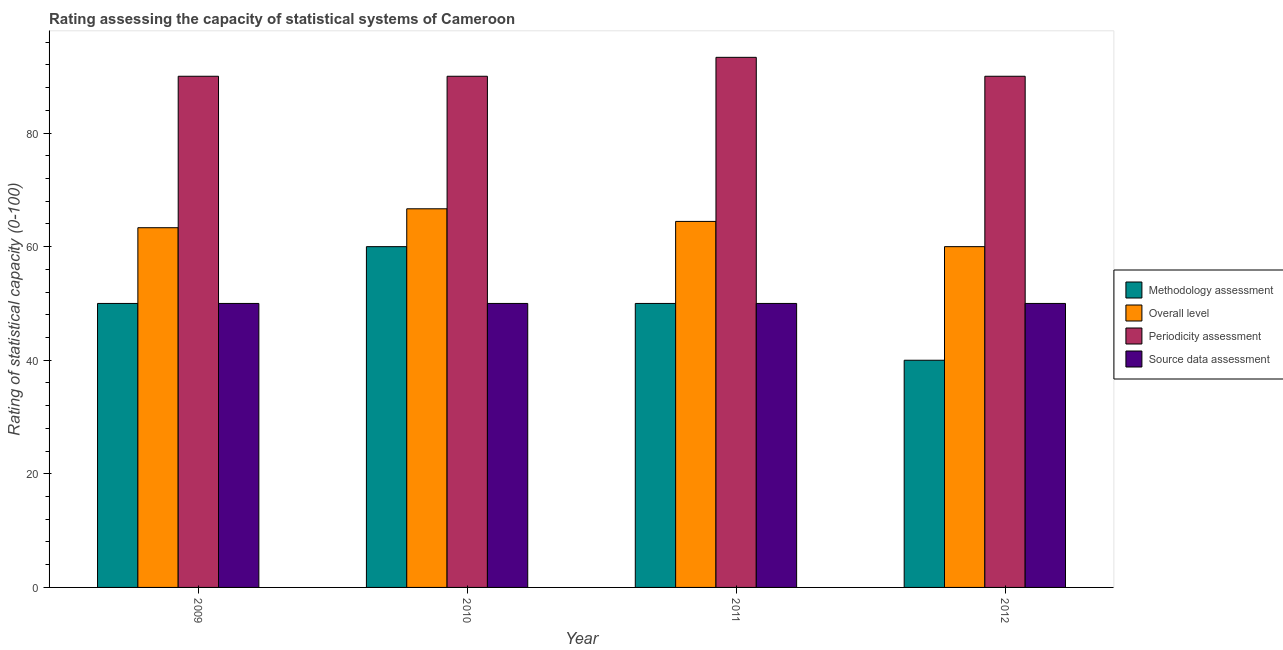How many groups of bars are there?
Provide a short and direct response. 4. How many bars are there on the 4th tick from the left?
Provide a short and direct response. 4. How many bars are there on the 4th tick from the right?
Offer a very short reply. 4. In how many cases, is the number of bars for a given year not equal to the number of legend labels?
Your answer should be very brief. 0. What is the overall level rating in 2011?
Make the answer very short. 64.44. Across all years, what is the maximum periodicity assessment rating?
Your answer should be compact. 93.33. Across all years, what is the minimum methodology assessment rating?
Provide a short and direct response. 40. In which year was the overall level rating maximum?
Give a very brief answer. 2010. In which year was the source data assessment rating minimum?
Ensure brevity in your answer.  2009. What is the total overall level rating in the graph?
Provide a succinct answer. 254.44. What is the difference between the methodology assessment rating in 2011 and that in 2012?
Ensure brevity in your answer.  10. What is the difference between the overall level rating in 2012 and the periodicity assessment rating in 2010?
Offer a very short reply. -6.67. What is the average methodology assessment rating per year?
Provide a short and direct response. 50. What is the ratio of the overall level rating in 2009 to that in 2012?
Keep it short and to the point. 1.06. Is the difference between the overall level rating in 2009 and 2010 greater than the difference between the methodology assessment rating in 2009 and 2010?
Offer a terse response. No. What is the difference between the highest and the second highest overall level rating?
Give a very brief answer. 2.22. What is the difference between the highest and the lowest overall level rating?
Provide a short and direct response. 6.67. In how many years, is the overall level rating greater than the average overall level rating taken over all years?
Offer a very short reply. 2. Is the sum of the source data assessment rating in 2009 and 2011 greater than the maximum periodicity assessment rating across all years?
Offer a terse response. Yes. Is it the case that in every year, the sum of the methodology assessment rating and source data assessment rating is greater than the sum of overall level rating and periodicity assessment rating?
Your response must be concise. No. What does the 3rd bar from the left in 2011 represents?
Ensure brevity in your answer.  Periodicity assessment. What does the 3rd bar from the right in 2012 represents?
Keep it short and to the point. Overall level. Is it the case that in every year, the sum of the methodology assessment rating and overall level rating is greater than the periodicity assessment rating?
Your response must be concise. Yes. How many bars are there?
Provide a succinct answer. 16. Are all the bars in the graph horizontal?
Give a very brief answer. No. What is the difference between two consecutive major ticks on the Y-axis?
Your answer should be compact. 20. Does the graph contain any zero values?
Offer a very short reply. No. Does the graph contain grids?
Provide a succinct answer. No. Where does the legend appear in the graph?
Make the answer very short. Center right. How many legend labels are there?
Make the answer very short. 4. How are the legend labels stacked?
Provide a succinct answer. Vertical. What is the title of the graph?
Provide a succinct answer. Rating assessing the capacity of statistical systems of Cameroon. What is the label or title of the X-axis?
Your answer should be very brief. Year. What is the label or title of the Y-axis?
Keep it short and to the point. Rating of statistical capacity (0-100). What is the Rating of statistical capacity (0-100) of Methodology assessment in 2009?
Keep it short and to the point. 50. What is the Rating of statistical capacity (0-100) of Overall level in 2009?
Your response must be concise. 63.33. What is the Rating of statistical capacity (0-100) of Periodicity assessment in 2009?
Your response must be concise. 90. What is the Rating of statistical capacity (0-100) in Source data assessment in 2009?
Make the answer very short. 50. What is the Rating of statistical capacity (0-100) of Methodology assessment in 2010?
Give a very brief answer. 60. What is the Rating of statistical capacity (0-100) of Overall level in 2010?
Keep it short and to the point. 66.67. What is the Rating of statistical capacity (0-100) of Overall level in 2011?
Offer a terse response. 64.44. What is the Rating of statistical capacity (0-100) of Periodicity assessment in 2011?
Provide a succinct answer. 93.33. What is the Rating of statistical capacity (0-100) of Source data assessment in 2011?
Your answer should be compact. 50. What is the Rating of statistical capacity (0-100) of Overall level in 2012?
Your answer should be very brief. 60. What is the Rating of statistical capacity (0-100) of Source data assessment in 2012?
Your answer should be very brief. 50. Across all years, what is the maximum Rating of statistical capacity (0-100) of Overall level?
Your response must be concise. 66.67. Across all years, what is the maximum Rating of statistical capacity (0-100) in Periodicity assessment?
Your response must be concise. 93.33. Across all years, what is the maximum Rating of statistical capacity (0-100) in Source data assessment?
Provide a succinct answer. 50. Across all years, what is the minimum Rating of statistical capacity (0-100) of Periodicity assessment?
Your answer should be very brief. 90. What is the total Rating of statistical capacity (0-100) in Methodology assessment in the graph?
Offer a very short reply. 200. What is the total Rating of statistical capacity (0-100) of Overall level in the graph?
Offer a very short reply. 254.44. What is the total Rating of statistical capacity (0-100) in Periodicity assessment in the graph?
Ensure brevity in your answer.  363.33. What is the total Rating of statistical capacity (0-100) in Source data assessment in the graph?
Provide a succinct answer. 200. What is the difference between the Rating of statistical capacity (0-100) in Overall level in 2009 and that in 2010?
Your answer should be compact. -3.33. What is the difference between the Rating of statistical capacity (0-100) in Periodicity assessment in 2009 and that in 2010?
Offer a very short reply. 0. What is the difference between the Rating of statistical capacity (0-100) of Source data assessment in 2009 and that in 2010?
Your response must be concise. 0. What is the difference between the Rating of statistical capacity (0-100) in Overall level in 2009 and that in 2011?
Keep it short and to the point. -1.11. What is the difference between the Rating of statistical capacity (0-100) of Periodicity assessment in 2009 and that in 2011?
Your answer should be compact. -3.33. What is the difference between the Rating of statistical capacity (0-100) in Methodology assessment in 2009 and that in 2012?
Ensure brevity in your answer.  10. What is the difference between the Rating of statistical capacity (0-100) in Overall level in 2009 and that in 2012?
Make the answer very short. 3.33. What is the difference between the Rating of statistical capacity (0-100) of Periodicity assessment in 2009 and that in 2012?
Your answer should be very brief. 0. What is the difference between the Rating of statistical capacity (0-100) of Source data assessment in 2009 and that in 2012?
Provide a short and direct response. 0. What is the difference between the Rating of statistical capacity (0-100) of Methodology assessment in 2010 and that in 2011?
Offer a very short reply. 10. What is the difference between the Rating of statistical capacity (0-100) of Overall level in 2010 and that in 2011?
Provide a succinct answer. 2.22. What is the difference between the Rating of statistical capacity (0-100) in Periodicity assessment in 2010 and that in 2011?
Ensure brevity in your answer.  -3.33. What is the difference between the Rating of statistical capacity (0-100) of Methodology assessment in 2010 and that in 2012?
Give a very brief answer. 20. What is the difference between the Rating of statistical capacity (0-100) in Overall level in 2011 and that in 2012?
Your answer should be very brief. 4.44. What is the difference between the Rating of statistical capacity (0-100) of Periodicity assessment in 2011 and that in 2012?
Provide a succinct answer. 3.33. What is the difference between the Rating of statistical capacity (0-100) of Source data assessment in 2011 and that in 2012?
Keep it short and to the point. 0. What is the difference between the Rating of statistical capacity (0-100) of Methodology assessment in 2009 and the Rating of statistical capacity (0-100) of Overall level in 2010?
Provide a succinct answer. -16.67. What is the difference between the Rating of statistical capacity (0-100) in Methodology assessment in 2009 and the Rating of statistical capacity (0-100) in Source data assessment in 2010?
Give a very brief answer. 0. What is the difference between the Rating of statistical capacity (0-100) of Overall level in 2009 and the Rating of statistical capacity (0-100) of Periodicity assessment in 2010?
Make the answer very short. -26.67. What is the difference between the Rating of statistical capacity (0-100) in Overall level in 2009 and the Rating of statistical capacity (0-100) in Source data assessment in 2010?
Give a very brief answer. 13.33. What is the difference between the Rating of statistical capacity (0-100) in Methodology assessment in 2009 and the Rating of statistical capacity (0-100) in Overall level in 2011?
Your answer should be very brief. -14.44. What is the difference between the Rating of statistical capacity (0-100) in Methodology assessment in 2009 and the Rating of statistical capacity (0-100) in Periodicity assessment in 2011?
Your answer should be very brief. -43.33. What is the difference between the Rating of statistical capacity (0-100) of Methodology assessment in 2009 and the Rating of statistical capacity (0-100) of Source data assessment in 2011?
Offer a very short reply. 0. What is the difference between the Rating of statistical capacity (0-100) in Overall level in 2009 and the Rating of statistical capacity (0-100) in Periodicity assessment in 2011?
Make the answer very short. -30. What is the difference between the Rating of statistical capacity (0-100) of Overall level in 2009 and the Rating of statistical capacity (0-100) of Source data assessment in 2011?
Offer a terse response. 13.33. What is the difference between the Rating of statistical capacity (0-100) in Methodology assessment in 2009 and the Rating of statistical capacity (0-100) in Source data assessment in 2012?
Provide a succinct answer. 0. What is the difference between the Rating of statistical capacity (0-100) in Overall level in 2009 and the Rating of statistical capacity (0-100) in Periodicity assessment in 2012?
Your answer should be compact. -26.67. What is the difference between the Rating of statistical capacity (0-100) in Overall level in 2009 and the Rating of statistical capacity (0-100) in Source data assessment in 2012?
Give a very brief answer. 13.33. What is the difference between the Rating of statistical capacity (0-100) of Periodicity assessment in 2009 and the Rating of statistical capacity (0-100) of Source data assessment in 2012?
Your answer should be compact. 40. What is the difference between the Rating of statistical capacity (0-100) in Methodology assessment in 2010 and the Rating of statistical capacity (0-100) in Overall level in 2011?
Your response must be concise. -4.44. What is the difference between the Rating of statistical capacity (0-100) in Methodology assessment in 2010 and the Rating of statistical capacity (0-100) in Periodicity assessment in 2011?
Your answer should be compact. -33.33. What is the difference between the Rating of statistical capacity (0-100) in Methodology assessment in 2010 and the Rating of statistical capacity (0-100) in Source data assessment in 2011?
Provide a succinct answer. 10. What is the difference between the Rating of statistical capacity (0-100) in Overall level in 2010 and the Rating of statistical capacity (0-100) in Periodicity assessment in 2011?
Your answer should be very brief. -26.67. What is the difference between the Rating of statistical capacity (0-100) of Overall level in 2010 and the Rating of statistical capacity (0-100) of Source data assessment in 2011?
Offer a very short reply. 16.67. What is the difference between the Rating of statistical capacity (0-100) of Periodicity assessment in 2010 and the Rating of statistical capacity (0-100) of Source data assessment in 2011?
Give a very brief answer. 40. What is the difference between the Rating of statistical capacity (0-100) of Methodology assessment in 2010 and the Rating of statistical capacity (0-100) of Overall level in 2012?
Provide a short and direct response. 0. What is the difference between the Rating of statistical capacity (0-100) of Overall level in 2010 and the Rating of statistical capacity (0-100) of Periodicity assessment in 2012?
Offer a terse response. -23.33. What is the difference between the Rating of statistical capacity (0-100) in Overall level in 2010 and the Rating of statistical capacity (0-100) in Source data assessment in 2012?
Ensure brevity in your answer.  16.67. What is the difference between the Rating of statistical capacity (0-100) in Methodology assessment in 2011 and the Rating of statistical capacity (0-100) in Overall level in 2012?
Your answer should be very brief. -10. What is the difference between the Rating of statistical capacity (0-100) of Methodology assessment in 2011 and the Rating of statistical capacity (0-100) of Source data assessment in 2012?
Your answer should be very brief. 0. What is the difference between the Rating of statistical capacity (0-100) of Overall level in 2011 and the Rating of statistical capacity (0-100) of Periodicity assessment in 2012?
Offer a terse response. -25.56. What is the difference between the Rating of statistical capacity (0-100) in Overall level in 2011 and the Rating of statistical capacity (0-100) in Source data assessment in 2012?
Keep it short and to the point. 14.44. What is the difference between the Rating of statistical capacity (0-100) of Periodicity assessment in 2011 and the Rating of statistical capacity (0-100) of Source data assessment in 2012?
Offer a very short reply. 43.33. What is the average Rating of statistical capacity (0-100) in Overall level per year?
Provide a succinct answer. 63.61. What is the average Rating of statistical capacity (0-100) in Periodicity assessment per year?
Give a very brief answer. 90.83. What is the average Rating of statistical capacity (0-100) of Source data assessment per year?
Your answer should be compact. 50. In the year 2009, what is the difference between the Rating of statistical capacity (0-100) of Methodology assessment and Rating of statistical capacity (0-100) of Overall level?
Your answer should be very brief. -13.33. In the year 2009, what is the difference between the Rating of statistical capacity (0-100) of Methodology assessment and Rating of statistical capacity (0-100) of Source data assessment?
Your answer should be very brief. 0. In the year 2009, what is the difference between the Rating of statistical capacity (0-100) of Overall level and Rating of statistical capacity (0-100) of Periodicity assessment?
Keep it short and to the point. -26.67. In the year 2009, what is the difference between the Rating of statistical capacity (0-100) in Overall level and Rating of statistical capacity (0-100) in Source data assessment?
Your answer should be compact. 13.33. In the year 2010, what is the difference between the Rating of statistical capacity (0-100) in Methodology assessment and Rating of statistical capacity (0-100) in Overall level?
Provide a succinct answer. -6.67. In the year 2010, what is the difference between the Rating of statistical capacity (0-100) in Methodology assessment and Rating of statistical capacity (0-100) in Source data assessment?
Your answer should be compact. 10. In the year 2010, what is the difference between the Rating of statistical capacity (0-100) of Overall level and Rating of statistical capacity (0-100) of Periodicity assessment?
Provide a succinct answer. -23.33. In the year 2010, what is the difference between the Rating of statistical capacity (0-100) in Overall level and Rating of statistical capacity (0-100) in Source data assessment?
Make the answer very short. 16.67. In the year 2010, what is the difference between the Rating of statistical capacity (0-100) of Periodicity assessment and Rating of statistical capacity (0-100) of Source data assessment?
Make the answer very short. 40. In the year 2011, what is the difference between the Rating of statistical capacity (0-100) in Methodology assessment and Rating of statistical capacity (0-100) in Overall level?
Offer a very short reply. -14.44. In the year 2011, what is the difference between the Rating of statistical capacity (0-100) of Methodology assessment and Rating of statistical capacity (0-100) of Periodicity assessment?
Give a very brief answer. -43.33. In the year 2011, what is the difference between the Rating of statistical capacity (0-100) in Overall level and Rating of statistical capacity (0-100) in Periodicity assessment?
Provide a succinct answer. -28.89. In the year 2011, what is the difference between the Rating of statistical capacity (0-100) of Overall level and Rating of statistical capacity (0-100) of Source data assessment?
Offer a terse response. 14.44. In the year 2011, what is the difference between the Rating of statistical capacity (0-100) in Periodicity assessment and Rating of statistical capacity (0-100) in Source data assessment?
Your response must be concise. 43.33. In the year 2012, what is the difference between the Rating of statistical capacity (0-100) of Methodology assessment and Rating of statistical capacity (0-100) of Overall level?
Make the answer very short. -20. In the year 2012, what is the difference between the Rating of statistical capacity (0-100) in Methodology assessment and Rating of statistical capacity (0-100) in Periodicity assessment?
Give a very brief answer. -50. In the year 2012, what is the difference between the Rating of statistical capacity (0-100) of Methodology assessment and Rating of statistical capacity (0-100) of Source data assessment?
Provide a short and direct response. -10. In the year 2012, what is the difference between the Rating of statistical capacity (0-100) in Overall level and Rating of statistical capacity (0-100) in Periodicity assessment?
Provide a succinct answer. -30. In the year 2012, what is the difference between the Rating of statistical capacity (0-100) in Overall level and Rating of statistical capacity (0-100) in Source data assessment?
Keep it short and to the point. 10. In the year 2012, what is the difference between the Rating of statistical capacity (0-100) of Periodicity assessment and Rating of statistical capacity (0-100) of Source data assessment?
Your answer should be compact. 40. What is the ratio of the Rating of statistical capacity (0-100) of Periodicity assessment in 2009 to that in 2010?
Provide a succinct answer. 1. What is the ratio of the Rating of statistical capacity (0-100) in Source data assessment in 2009 to that in 2010?
Give a very brief answer. 1. What is the ratio of the Rating of statistical capacity (0-100) of Methodology assessment in 2009 to that in 2011?
Provide a short and direct response. 1. What is the ratio of the Rating of statistical capacity (0-100) of Overall level in 2009 to that in 2011?
Ensure brevity in your answer.  0.98. What is the ratio of the Rating of statistical capacity (0-100) in Source data assessment in 2009 to that in 2011?
Ensure brevity in your answer.  1. What is the ratio of the Rating of statistical capacity (0-100) of Overall level in 2009 to that in 2012?
Offer a terse response. 1.06. What is the ratio of the Rating of statistical capacity (0-100) of Periodicity assessment in 2009 to that in 2012?
Ensure brevity in your answer.  1. What is the ratio of the Rating of statistical capacity (0-100) in Overall level in 2010 to that in 2011?
Provide a succinct answer. 1.03. What is the ratio of the Rating of statistical capacity (0-100) of Source data assessment in 2010 to that in 2011?
Ensure brevity in your answer.  1. What is the ratio of the Rating of statistical capacity (0-100) of Overall level in 2010 to that in 2012?
Make the answer very short. 1.11. What is the ratio of the Rating of statistical capacity (0-100) of Source data assessment in 2010 to that in 2012?
Give a very brief answer. 1. What is the ratio of the Rating of statistical capacity (0-100) of Methodology assessment in 2011 to that in 2012?
Make the answer very short. 1.25. What is the ratio of the Rating of statistical capacity (0-100) in Overall level in 2011 to that in 2012?
Provide a short and direct response. 1.07. What is the ratio of the Rating of statistical capacity (0-100) of Source data assessment in 2011 to that in 2012?
Keep it short and to the point. 1. What is the difference between the highest and the second highest Rating of statistical capacity (0-100) in Overall level?
Offer a terse response. 2.22. What is the difference between the highest and the second highest Rating of statistical capacity (0-100) of Periodicity assessment?
Give a very brief answer. 3.33. What is the difference between the highest and the second highest Rating of statistical capacity (0-100) of Source data assessment?
Provide a succinct answer. 0. 